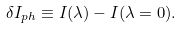<formula> <loc_0><loc_0><loc_500><loc_500>\delta I _ { p h } \equiv I ( \lambda ) - I ( \lambda = 0 ) .</formula> 